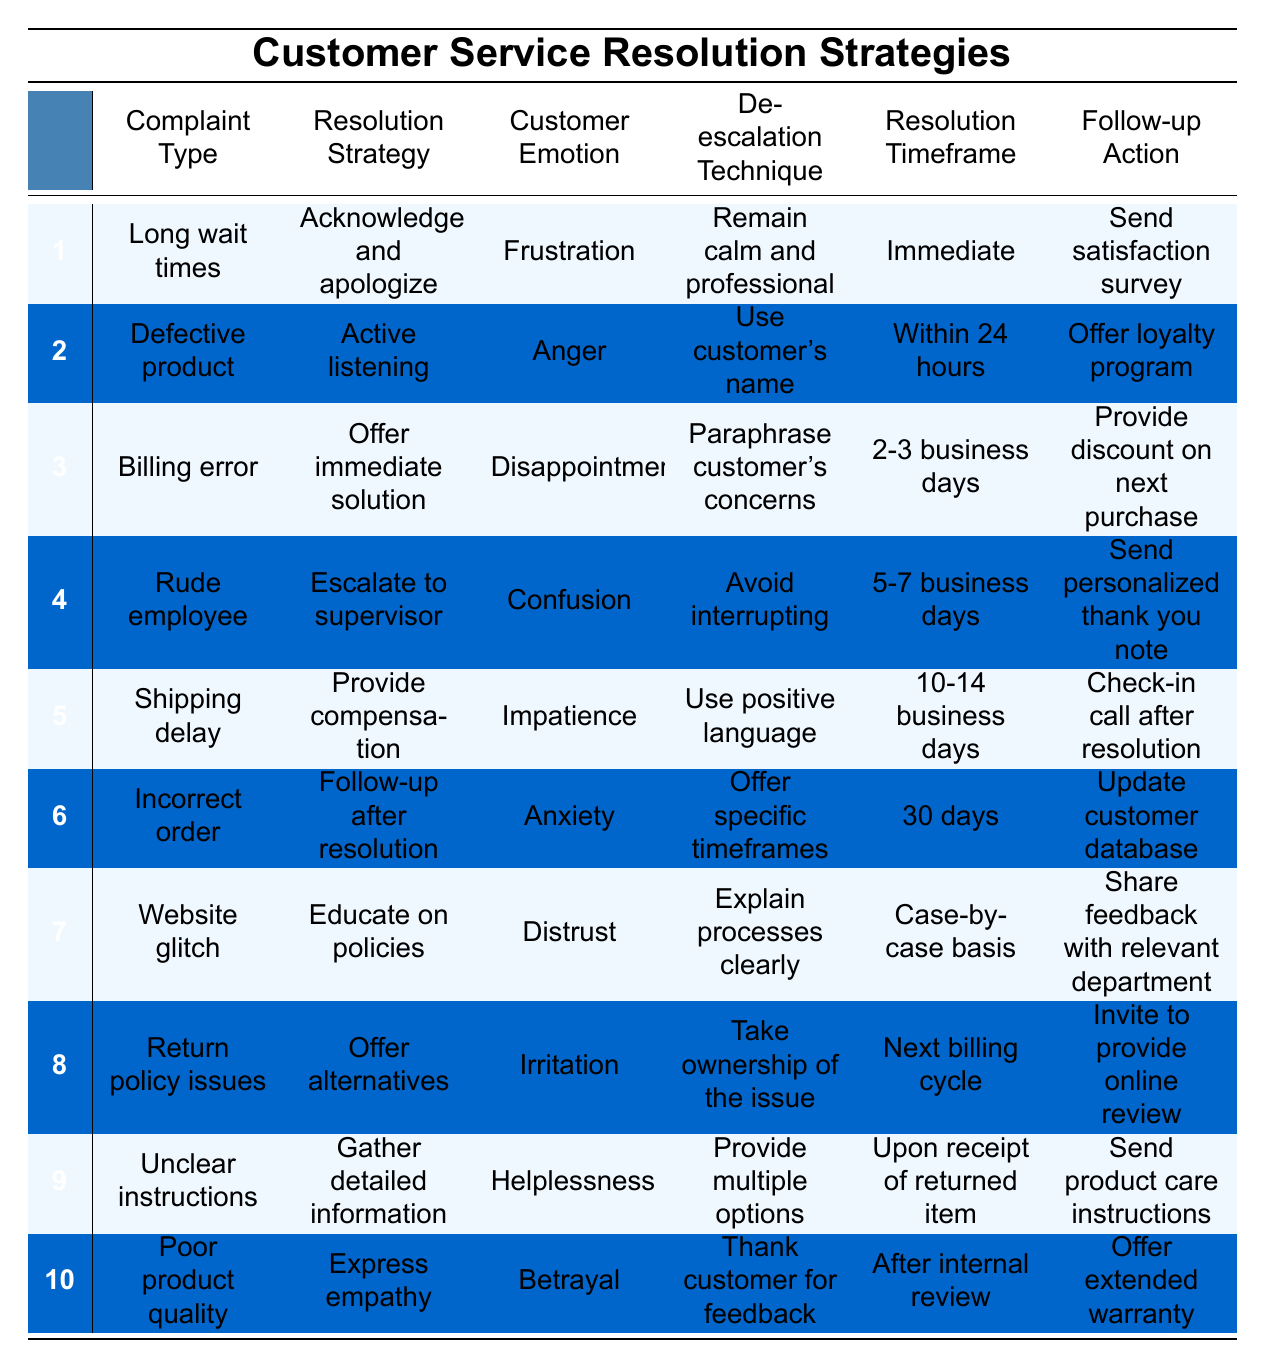What is the resolution strategy for "Defective product"? In the row for "Defective product," the resolution strategy listed is "Active listening."
Answer: Active listening How many complaints are associated with "Frustration"? There is one corresponding entry for "Frustration," which is "Long wait times."
Answer: 1 Is "Provide compensation" a resolution strategy for "Shipping delay"? Yes, the table indicates that "Provide compensation" is the resolution strategy associated with "Shipping delay."
Answer: Yes What are the follow-up actions for the "Incorrect order"? The follow-up action listed for "Incorrect order" is "Update customer database."
Answer: Update customer database Which customer emotion is linked to "Rude employee"? The emotion associated with "Rude employee" is "Confusion."
Answer: Confusion How many complaints have a resolution timeframe of "Within 24 hours"? There is one complaint, "Defective product," that has a resolution timeframe of "Within 24 hours."
Answer: 1 What is the de-escalation technique suggested for "Shipping delay"? The technique suggested for "Shipping delay" is "Use positive language."
Answer: Use positive language Which resolution strategy is most common among the complaints listed? The table does not provide a count of how often each strategy is used, so a direct answer is not possible. However, common strategies may include listening or apologizing based on the provided resolutions.
Answer: Not determinable from the table What are the emotions associated with the complaint types about website issues? The complaint type "Website glitch" is associated with the emotion "Distrust."
Answer: Distrust For "Poor product quality," what is the stated resolution timeframe? The stated resolution timeframe for "Poor product quality" is "After internal review."
Answer: After internal review If a customer expresses "Anger," which resolution strategy should be used? For "Anger," the recommended resolution strategy is "Active listening."
Answer: Active listening How many follow-up actions involve providing discounts or offers? There are two follow-up actions that involve providing discounts or offers: "Offer loyalty program" and "Provide discount on next purchase."
Answer: 2 What are examples of de-escalation techniques that can be used for "Billing error"? The suggested de-escalation techniques are "Paraphrase customer's concerns."
Answer: Paraphrase customer's concerns Are there any resolution strategies that recommend "Offering alternatives"? Yes, "Offering alternatives" is suggested for the complaint type "Return policy issues."
Answer: Yes Which complaint type has a longer resolution timeframe, "Incorrect order" or "Rude employee"? "Incorrect order" has a resolution timeframe of 30 days, while "Rude employee" has 5-7 business days; thus, "Incorrect order" has the longer timeframe.
Answer: Incorrect order If a customer has a complaint about "Unclear instructions," what is the primary follow-up action to take? For "Unclear instructions," the primary follow-up action is to "Send product care instructions."
Answer: Send product care instructions 